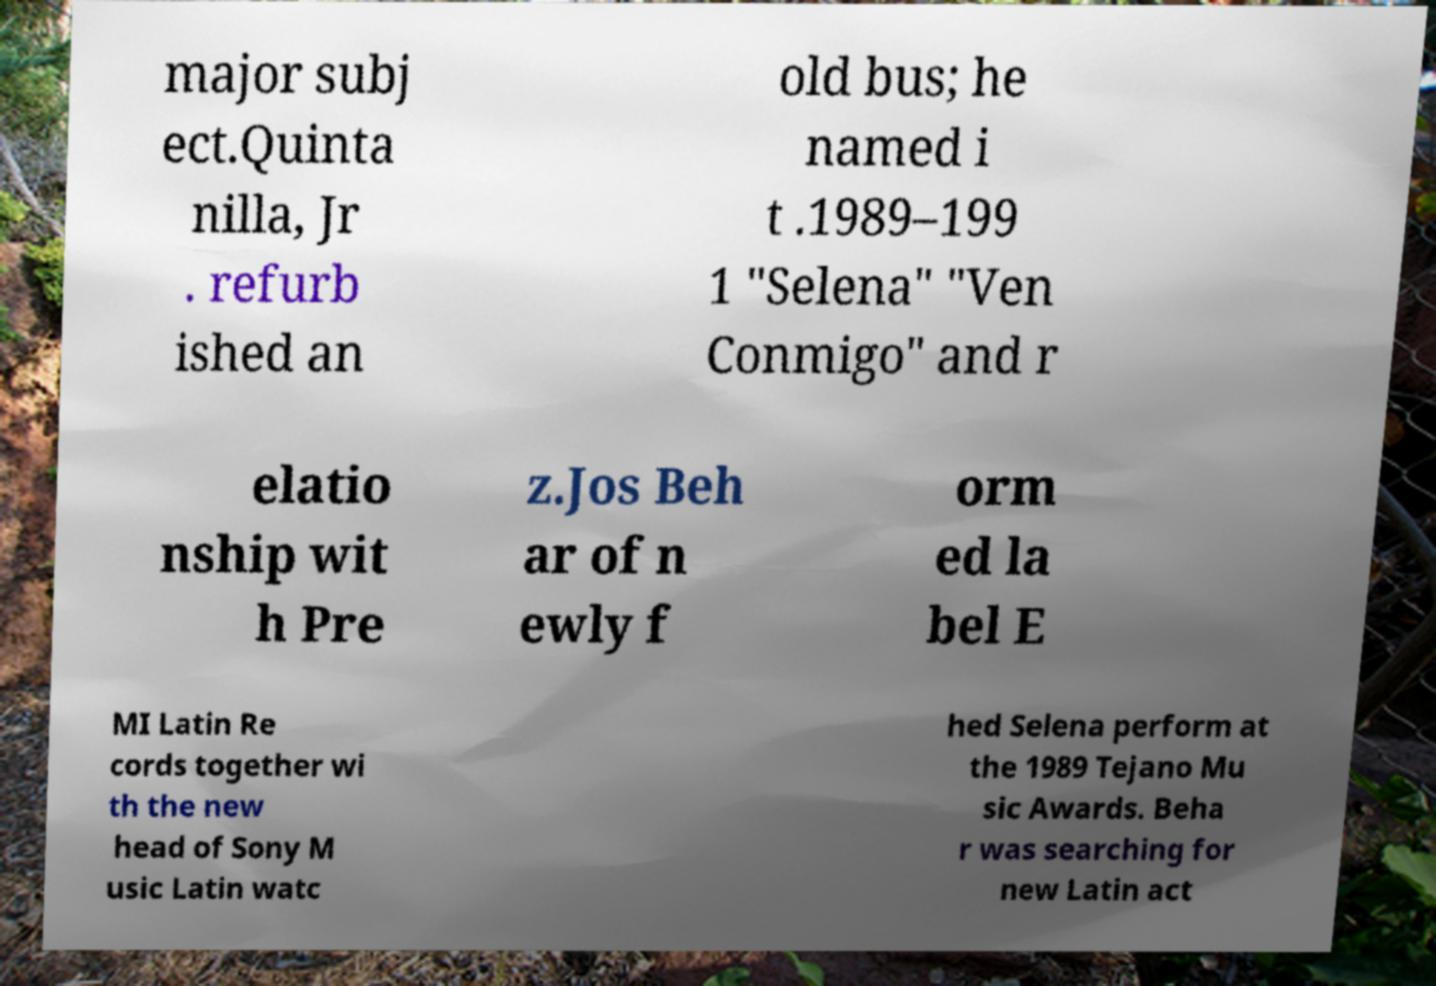Could you extract and type out the text from this image? major subj ect.Quinta nilla, Jr . refurb ished an old bus; he named i t .1989–199 1 "Selena" "Ven Conmigo" and r elatio nship wit h Pre z.Jos Beh ar of n ewly f orm ed la bel E MI Latin Re cords together wi th the new head of Sony M usic Latin watc hed Selena perform at the 1989 Tejano Mu sic Awards. Beha r was searching for new Latin act 